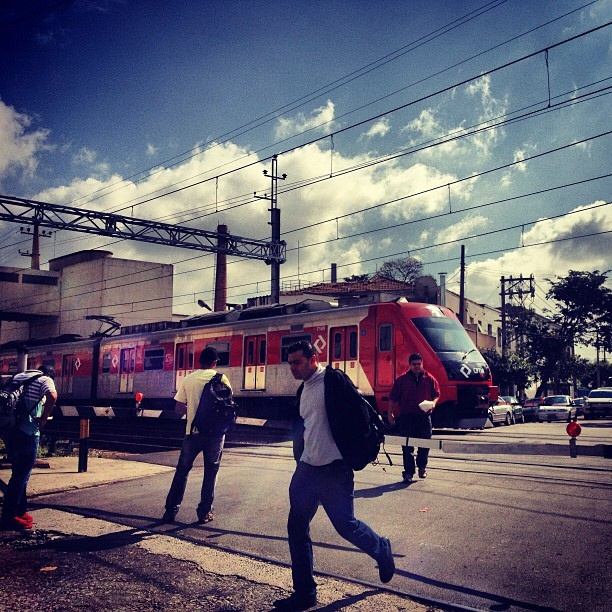Describe the objects in this image and their specific colors. I can see train in navy and purple tones, people in navy, black, purple, and gray tones, people in navy, darkgray, and tan tones, people in navy, black, purple, and lightgray tones, and people in navy, darkgray, and purple tones in this image. 